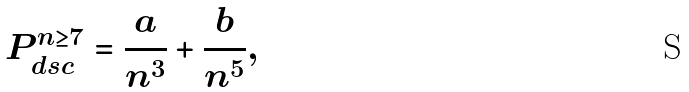<formula> <loc_0><loc_0><loc_500><loc_500>P ^ { n \geq 7 } _ { d s c } = \frac { a } { n ^ { 3 } } + \frac { b } { n ^ { 5 } } ,</formula> 